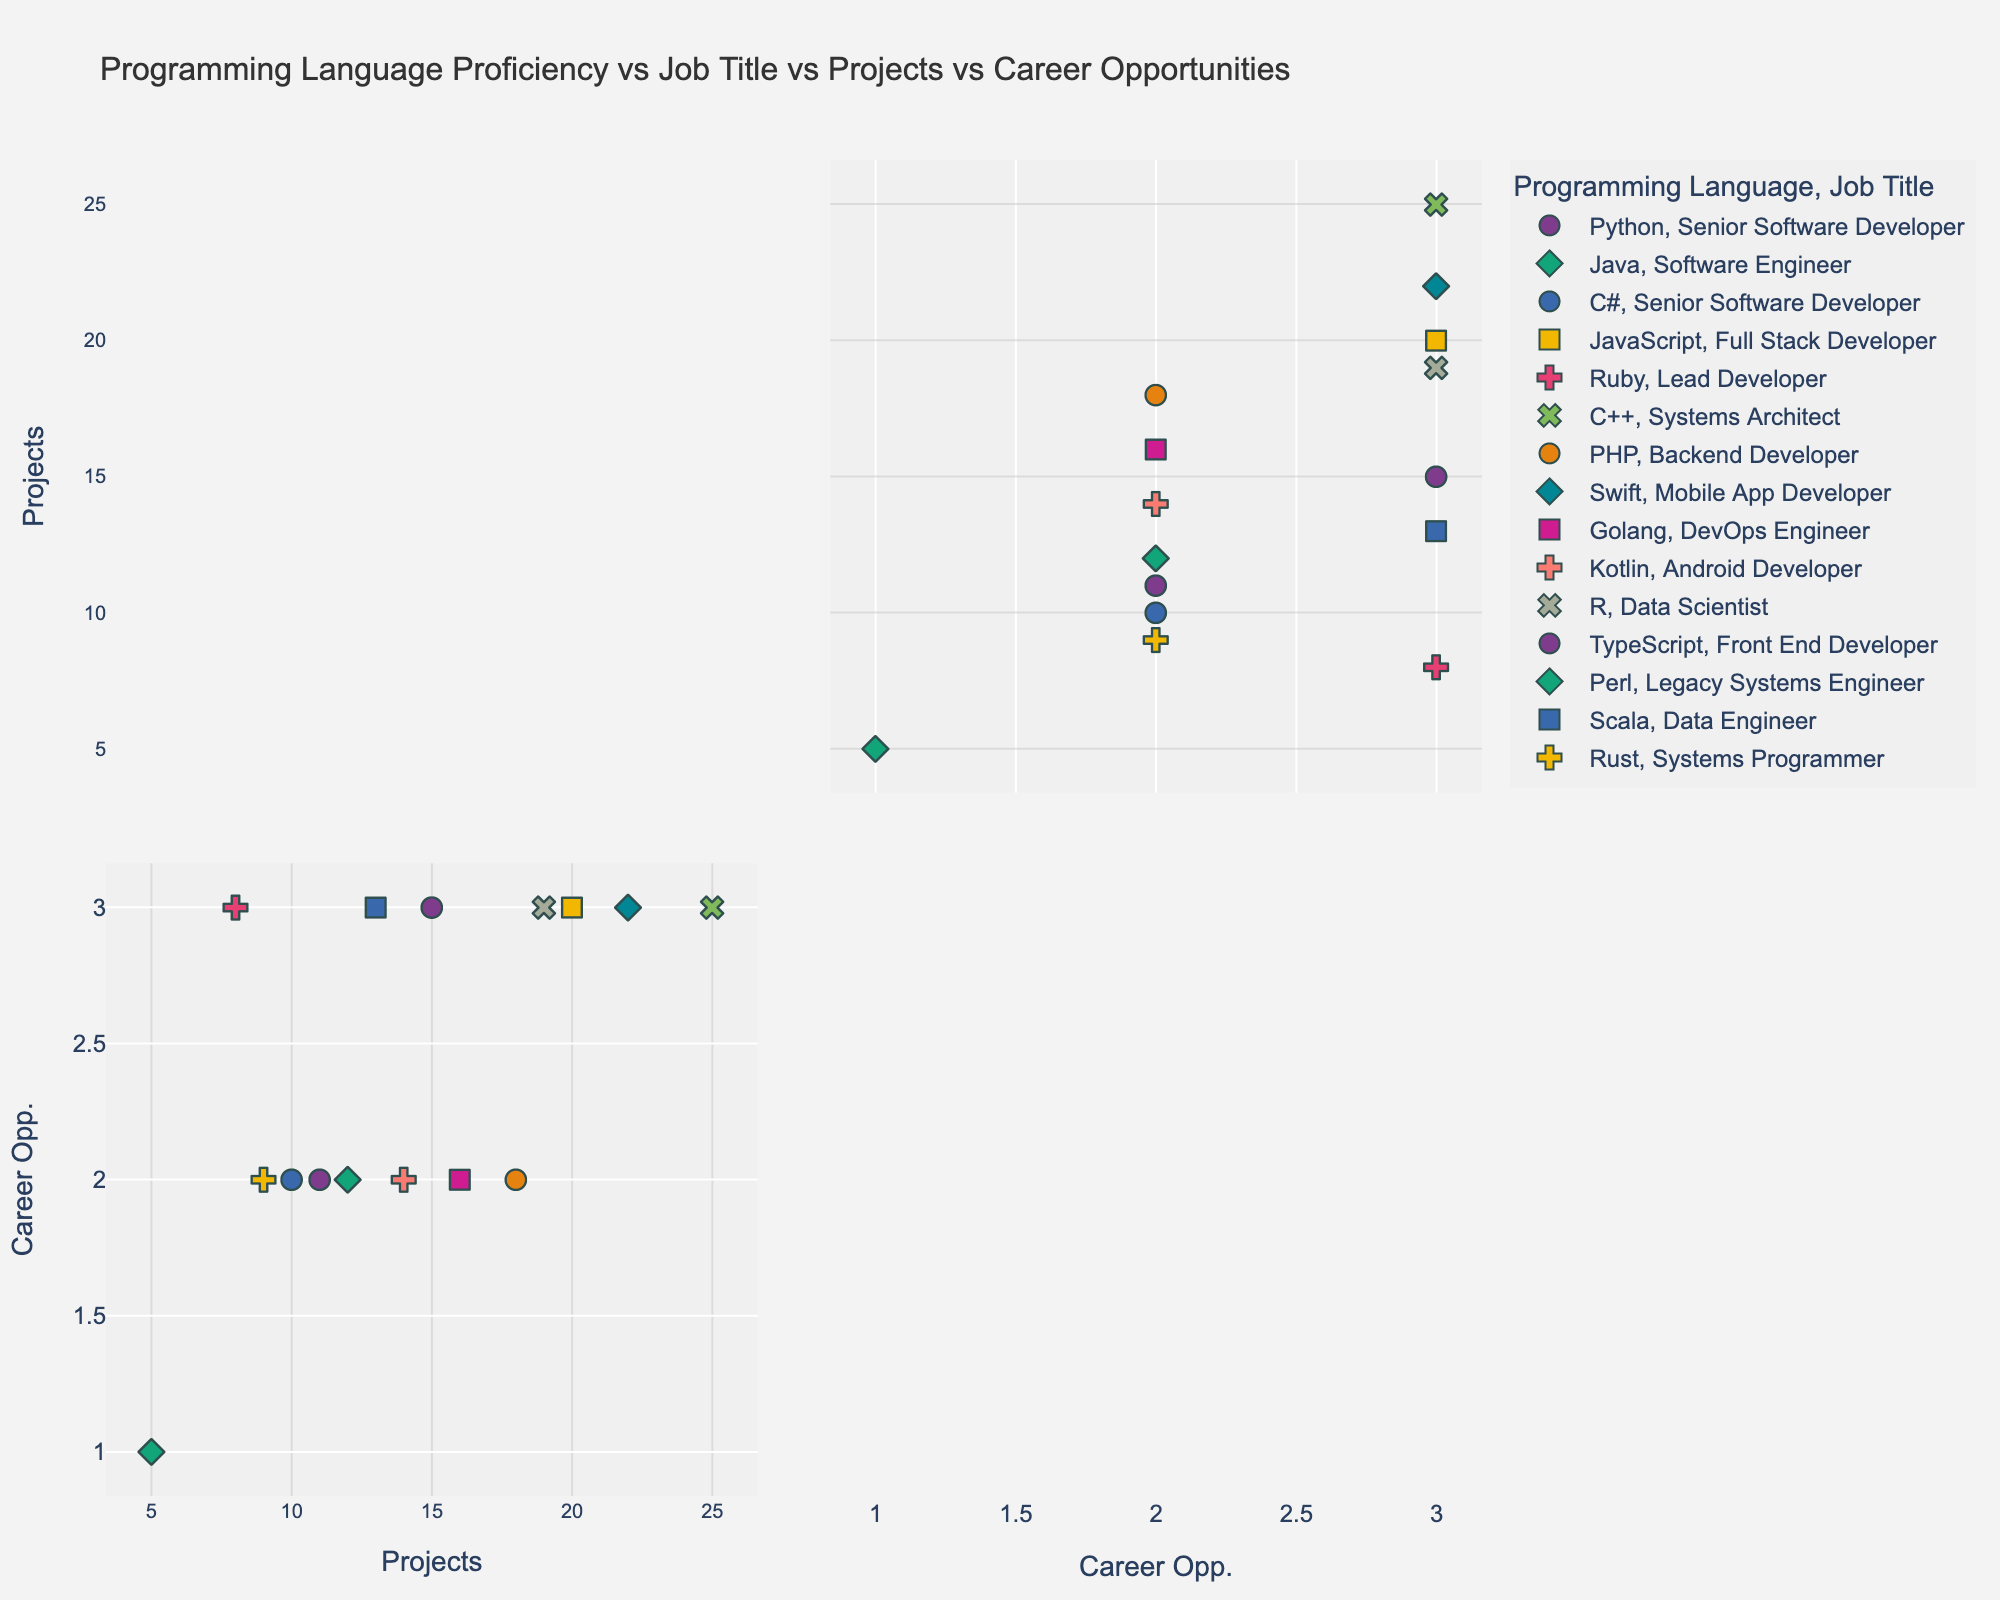Which programming language has the highest "Number of Projects Completed"? Identify the programming language with the maximum value on the "Number of Projects Completed" axis. Look for the highest point on the scatter plot associated with the "Number of Projects Completed". In this case, C++ (Systems Architect) has completed 25 projects.
Answer: C++ Describe the color coding used in this scatter plot matrix. Each color represents a different programming language, allowing the viewer to distinguish between different data points based on "Programming Language". Refer to the legend on the plot to see the specific mapping.
Answer: Colors represent different languages Which job titles have the highest "Career Advancement Opportunities"? To find the job titles with the highest "Career Advancement Opportunities", locate the points that reach the maximum value (3) on the "Career Advancement Opportunities" axis. Check the corresponding symbols (shapes) for job titles. There are multiple such as "Senior Software Developer", "Full Stack Developer", etc.
Answer: Multiple (e.g., Senior Software Developer, Full Stack Developer) How many data points represent Backend Developers, and what are their values for "Number of Projects Completed"? Identify the symbols associated with "Backend Developer" and count them. The corresponding data values can be seen from the points' positions. There is 1 "Backend Developer" with 18 projects completed.
Answer: 1 point, 18 projects Do any programming languages appear more than twice in the dataset? Check the legend and observe the frequency of each color. Only one instance per language appears, so no language appears more than twice.
Answer: No Which job title is represented by an ‘x’ symbol and what are its data values? Identify the symbol 'x' on the plot and check its position to determine the job title based on the legend and the axes. The 'x' symbol represents a "Systems Programmer", with 9 projects completed and medium (2) career opportunities.
Answer: Systems Programmer, 9 projects, medium opportunities What is the median number of projects completed by Senior Software Developers? To find the median, list the number of projects completed by Senior Software Developers (15 for Python, 10 for C#) and calculate the middle value. Since there are two values, the median is the average of 15 and 10, which is (15+10)/2 = 12.5.
Answer: 12.5 Compare the number of projects completed between the Mobile App Developer and the Android Developer. Identify the points corresponding to "Mobile App Developer" (Swift) and "Android Developer" (Kotlin). The Mobile App Developer has completed 22 projects, while the Android Developer has completed 14 projects. Compare these values.
Answer: Mobile App Developer: 22, Android Developer: 14 